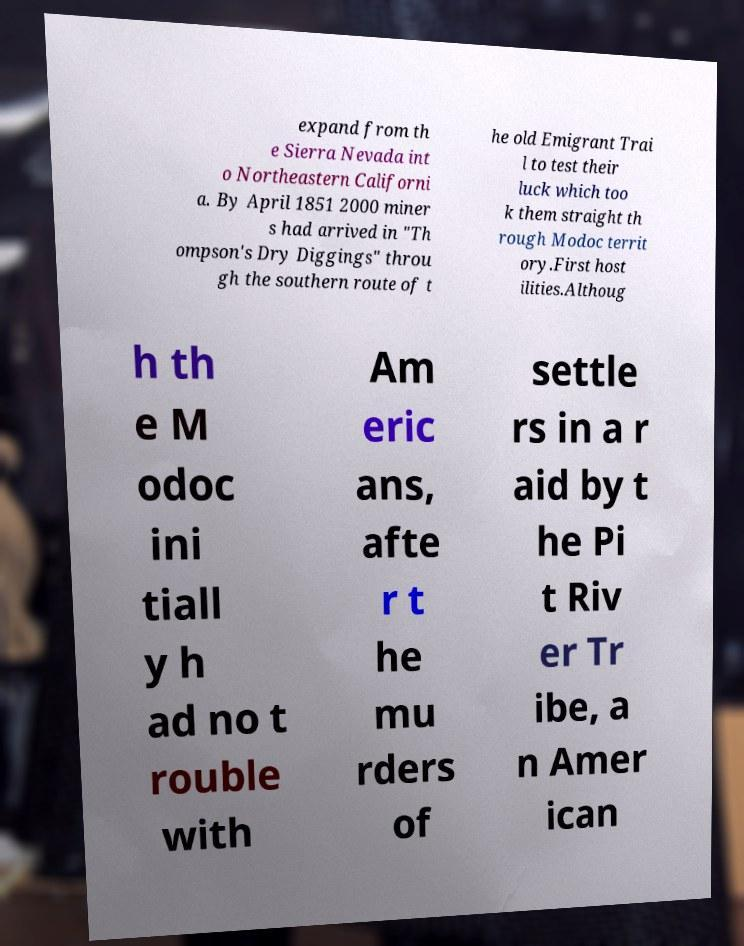Could you extract and type out the text from this image? expand from th e Sierra Nevada int o Northeastern Californi a. By April 1851 2000 miner s had arrived in "Th ompson's Dry Diggings" throu gh the southern route of t he old Emigrant Trai l to test their luck which too k them straight th rough Modoc territ ory.First host ilities.Althoug h th e M odoc ini tiall y h ad no t rouble with Am eric ans, afte r t he mu rders of settle rs in a r aid by t he Pi t Riv er Tr ibe, a n Amer ican 